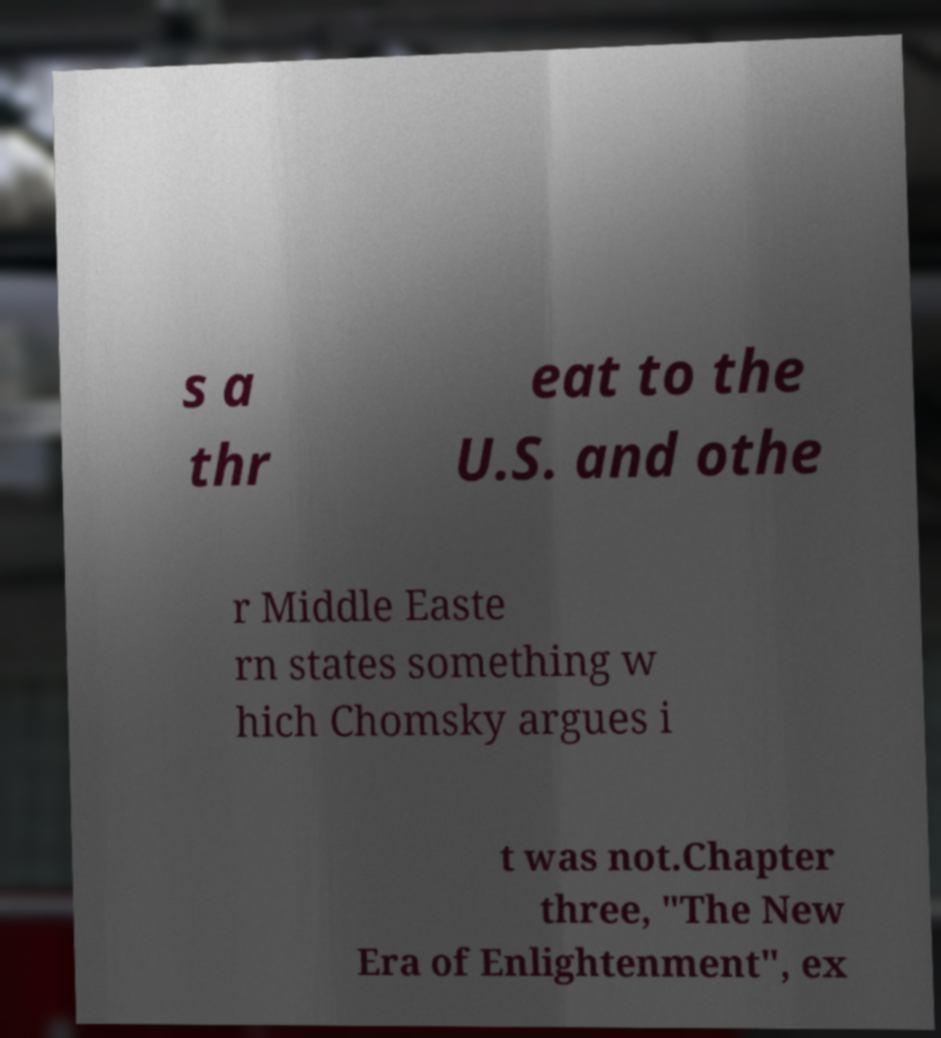Please read and relay the text visible in this image. What does it say? s a thr eat to the U.S. and othe r Middle Easte rn states something w hich Chomsky argues i t was not.Chapter three, "The New Era of Enlightenment", ex 